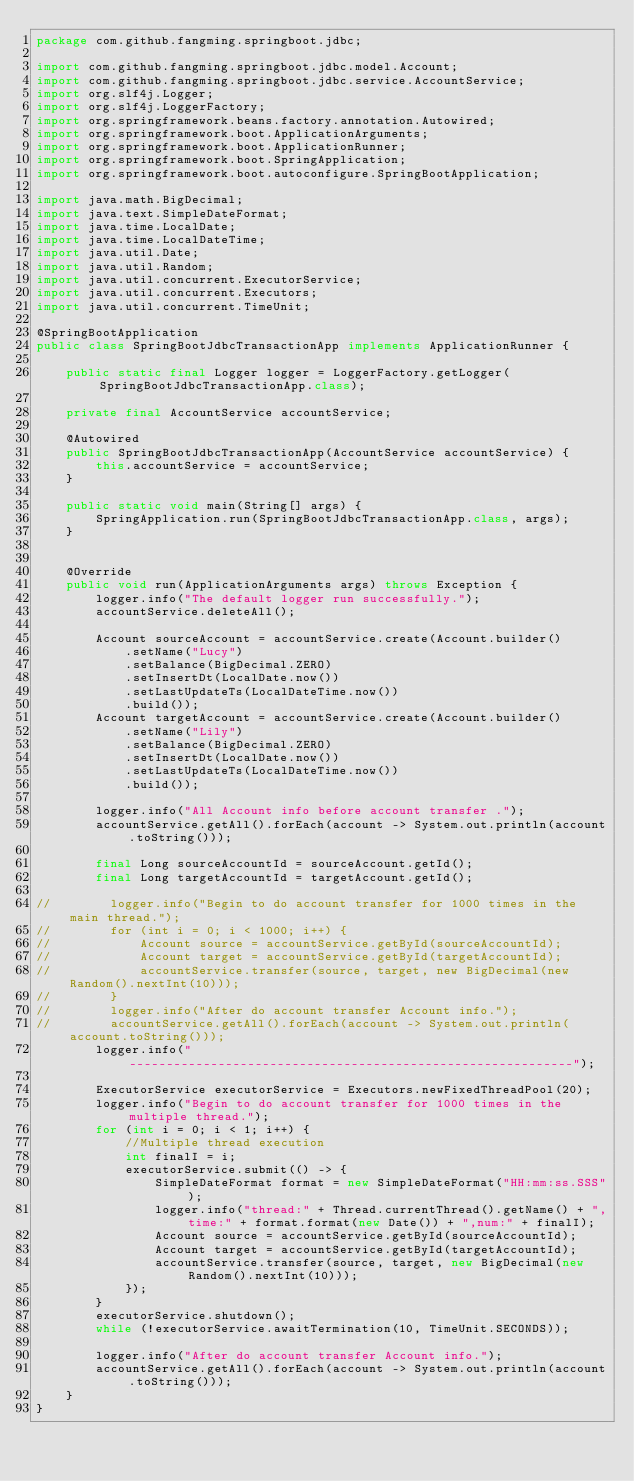Convert code to text. <code><loc_0><loc_0><loc_500><loc_500><_Java_>package com.github.fangming.springboot.jdbc;

import com.github.fangming.springboot.jdbc.model.Account;
import com.github.fangming.springboot.jdbc.service.AccountService;
import org.slf4j.Logger;
import org.slf4j.LoggerFactory;
import org.springframework.beans.factory.annotation.Autowired;
import org.springframework.boot.ApplicationArguments;
import org.springframework.boot.ApplicationRunner;
import org.springframework.boot.SpringApplication;
import org.springframework.boot.autoconfigure.SpringBootApplication;

import java.math.BigDecimal;
import java.text.SimpleDateFormat;
import java.time.LocalDate;
import java.time.LocalDateTime;
import java.util.Date;
import java.util.Random;
import java.util.concurrent.ExecutorService;
import java.util.concurrent.Executors;
import java.util.concurrent.TimeUnit;

@SpringBootApplication
public class SpringBootJdbcTransactionApp implements ApplicationRunner {

    public static final Logger logger = LoggerFactory.getLogger(SpringBootJdbcTransactionApp.class);

    private final AccountService accountService;

    @Autowired
    public SpringBootJdbcTransactionApp(AccountService accountService) {
        this.accountService = accountService;
    }

    public static void main(String[] args) {
        SpringApplication.run(SpringBootJdbcTransactionApp.class, args);
    }


    @Override
    public void run(ApplicationArguments args) throws Exception {
        logger.info("The default logger run successfully.");
        accountService.deleteAll();

        Account sourceAccount = accountService.create(Account.builder()
            .setName("Lucy")
            .setBalance(BigDecimal.ZERO)
            .setInsertDt(LocalDate.now())
            .setLastUpdateTs(LocalDateTime.now())
            .build());
        Account targetAccount = accountService.create(Account.builder()
            .setName("Lily")
            .setBalance(BigDecimal.ZERO)
            .setInsertDt(LocalDate.now())
            .setLastUpdateTs(LocalDateTime.now())
            .build());

        logger.info("All Account info before account transfer .");
        accountService.getAll().forEach(account -> System.out.println(account.toString()));

        final Long sourceAccountId = sourceAccount.getId();
        final Long targetAccountId = targetAccount.getId();

//        logger.info("Begin to do account transfer for 1000 times in the main thread.");
//        for (int i = 0; i < 1000; i++) {
//            Account source = accountService.getById(sourceAccountId);
//            Account target = accountService.getById(targetAccountId);
//            accountService.transfer(source, target, new BigDecimal(new Random().nextInt(10)));
//        }
//        logger.info("After do account transfer Account info.");
//        accountService.getAll().forEach(account -> System.out.println(account.toString()));
        logger.info("------------------------------------------------------------");

        ExecutorService executorService = Executors.newFixedThreadPool(20);
        logger.info("Begin to do account transfer for 1000 times in the multiple thread.");
        for (int i = 0; i < 1; i++) {
            //Multiple thread execution
            int finalI = i;
            executorService.submit(() -> {
                SimpleDateFormat format = new SimpleDateFormat("HH:mm:ss.SSS");
                logger.info("thread:" + Thread.currentThread().getName() + ",time:" + format.format(new Date()) + ",num:" + finalI);
                Account source = accountService.getById(sourceAccountId);
                Account target = accountService.getById(targetAccountId);
                accountService.transfer(source, target, new BigDecimal(new Random().nextInt(10)));
            });
        }
        executorService.shutdown();
        while (!executorService.awaitTermination(10, TimeUnit.SECONDS));

        logger.info("After do account transfer Account info.");
        accountService.getAll().forEach(account -> System.out.println(account.toString()));
    }
}
</code> 